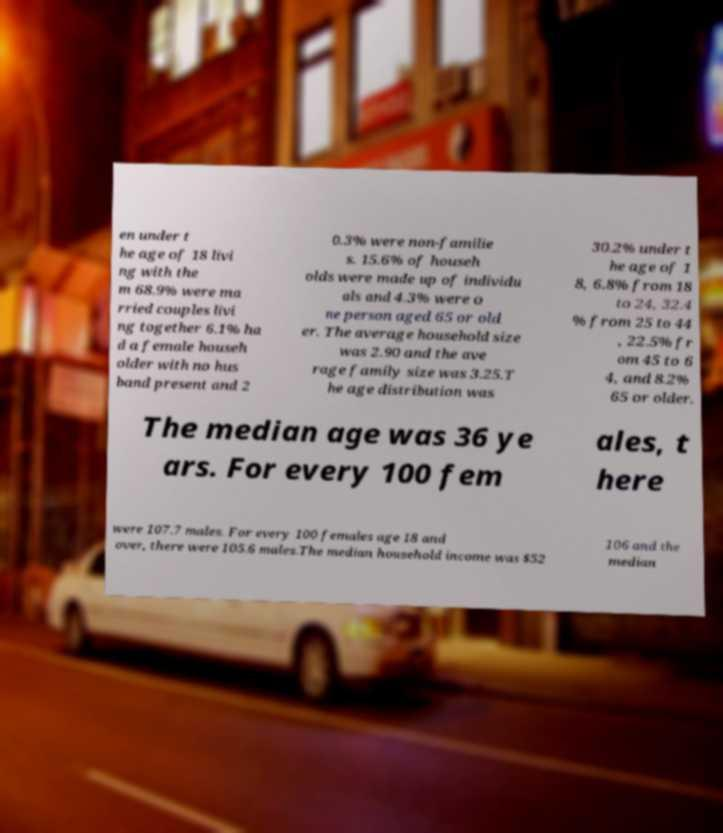Please read and relay the text visible in this image. What does it say? en under t he age of 18 livi ng with the m 68.9% were ma rried couples livi ng together 6.1% ha d a female househ older with no hus band present and 2 0.3% were non-familie s. 15.6% of househ olds were made up of individu als and 4.3% were o ne person aged 65 or old er. The average household size was 2.90 and the ave rage family size was 3.25.T he age distribution was 30.2% under t he age of 1 8, 6.8% from 18 to 24, 32.4 % from 25 to 44 , 22.5% fr om 45 to 6 4, and 8.2% 65 or older. The median age was 36 ye ars. For every 100 fem ales, t here were 107.7 males. For every 100 females age 18 and over, there were 105.6 males.The median household income was $52 106 and the median 